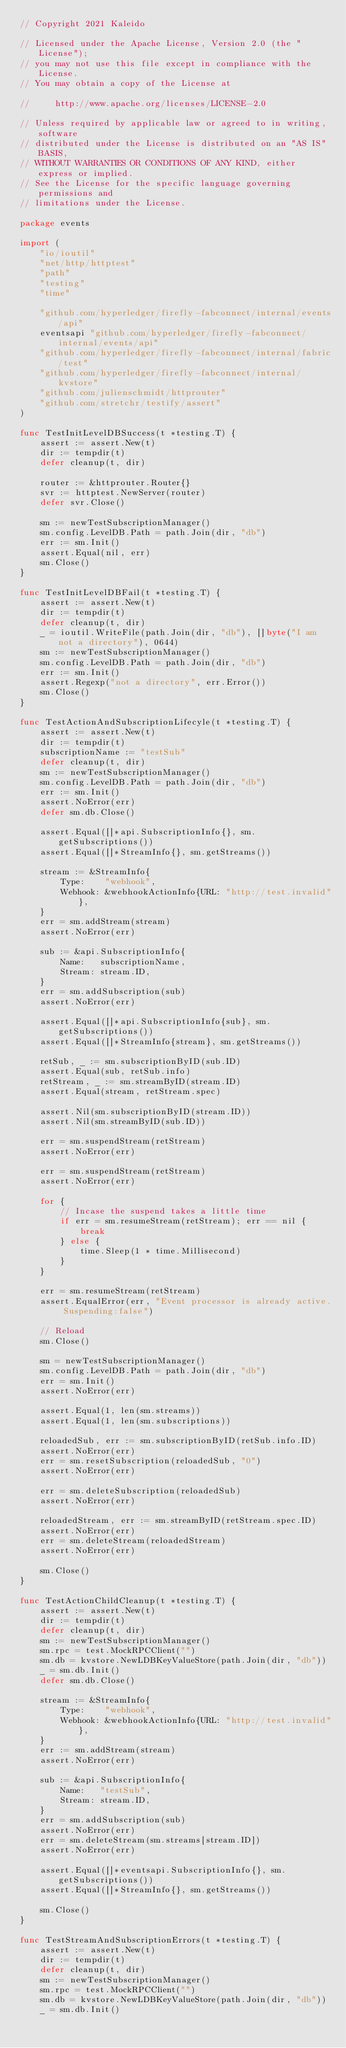<code> <loc_0><loc_0><loc_500><loc_500><_Go_>// Copyright 2021 Kaleido

// Licensed under the Apache License, Version 2.0 (the "License");
// you may not use this file except in compliance with the License.
// You may obtain a copy of the License at

//     http://www.apache.org/licenses/LICENSE-2.0

// Unless required by applicable law or agreed to in writing, software
// distributed under the License is distributed on an "AS IS" BASIS,
// WITHOUT WARRANTIES OR CONDITIONS OF ANY KIND, either express or implied.
// See the License for the specific language governing permissions and
// limitations under the License.

package events

import (
	"io/ioutil"
	"net/http/httptest"
	"path"
	"testing"
	"time"

	"github.com/hyperledger/firefly-fabconnect/internal/events/api"
	eventsapi "github.com/hyperledger/firefly-fabconnect/internal/events/api"
	"github.com/hyperledger/firefly-fabconnect/internal/fabric/test"
	"github.com/hyperledger/firefly-fabconnect/internal/kvstore"
	"github.com/julienschmidt/httprouter"
	"github.com/stretchr/testify/assert"
)

func TestInitLevelDBSuccess(t *testing.T) {
	assert := assert.New(t)
	dir := tempdir(t)
	defer cleanup(t, dir)

	router := &httprouter.Router{}
	svr := httptest.NewServer(router)
	defer svr.Close()

	sm := newTestSubscriptionManager()
	sm.config.LevelDB.Path = path.Join(dir, "db")
	err := sm.Init()
	assert.Equal(nil, err)
	sm.Close()
}

func TestInitLevelDBFail(t *testing.T) {
	assert := assert.New(t)
	dir := tempdir(t)
	defer cleanup(t, dir)
	_ = ioutil.WriteFile(path.Join(dir, "db"), []byte("I am not a directory"), 0644)
	sm := newTestSubscriptionManager()
	sm.config.LevelDB.Path = path.Join(dir, "db")
	err := sm.Init()
	assert.Regexp("not a directory", err.Error())
	sm.Close()
}

func TestActionAndSubscriptionLifecyle(t *testing.T) {
	assert := assert.New(t)
	dir := tempdir(t)
	subscriptionName := "testSub"
	defer cleanup(t, dir)
	sm := newTestSubscriptionManager()
	sm.config.LevelDB.Path = path.Join(dir, "db")
	err := sm.Init()
	assert.NoError(err)
	defer sm.db.Close()

	assert.Equal([]*api.SubscriptionInfo{}, sm.getSubscriptions())
	assert.Equal([]*StreamInfo{}, sm.getStreams())

	stream := &StreamInfo{
		Type:    "webhook",
		Webhook: &webhookActionInfo{URL: "http://test.invalid"},
	}
	err = sm.addStream(stream)
	assert.NoError(err)

	sub := &api.SubscriptionInfo{
		Name:   subscriptionName,
		Stream: stream.ID,
	}
	err = sm.addSubscription(sub)
	assert.NoError(err)

	assert.Equal([]*api.SubscriptionInfo{sub}, sm.getSubscriptions())
	assert.Equal([]*StreamInfo{stream}, sm.getStreams())

	retSub, _ := sm.subscriptionByID(sub.ID)
	assert.Equal(sub, retSub.info)
	retStream, _ := sm.streamByID(stream.ID)
	assert.Equal(stream, retStream.spec)

	assert.Nil(sm.subscriptionByID(stream.ID))
	assert.Nil(sm.streamByID(sub.ID))

	err = sm.suspendStream(retStream)
	assert.NoError(err)

	err = sm.suspendStream(retStream)
	assert.NoError(err)

	for {
		// Incase the suspend takes a little time
		if err = sm.resumeStream(retStream); err == nil {
			break
		} else {
			time.Sleep(1 * time.Millisecond)
		}
	}

	err = sm.resumeStream(retStream)
	assert.EqualError(err, "Event processor is already active. Suspending:false")

	// Reload
	sm.Close()

	sm = newTestSubscriptionManager()
	sm.config.LevelDB.Path = path.Join(dir, "db")
	err = sm.Init()
	assert.NoError(err)

	assert.Equal(1, len(sm.streams))
	assert.Equal(1, len(sm.subscriptions))

	reloadedSub, err := sm.subscriptionByID(retSub.info.ID)
	assert.NoError(err)
	err = sm.resetSubscription(reloadedSub, "0")
	assert.NoError(err)

	err = sm.deleteSubscription(reloadedSub)
	assert.NoError(err)

	reloadedStream, err := sm.streamByID(retStream.spec.ID)
	assert.NoError(err)
	err = sm.deleteStream(reloadedStream)
	assert.NoError(err)

	sm.Close()
}

func TestActionChildCleanup(t *testing.T) {
	assert := assert.New(t)
	dir := tempdir(t)
	defer cleanup(t, dir)
	sm := newTestSubscriptionManager()
	sm.rpc = test.MockRPCClient("")
	sm.db = kvstore.NewLDBKeyValueStore(path.Join(dir, "db"))
	_ = sm.db.Init()
	defer sm.db.Close()

	stream := &StreamInfo{
		Type:    "webhook",
		Webhook: &webhookActionInfo{URL: "http://test.invalid"},
	}
	err := sm.addStream(stream)
	assert.NoError(err)

	sub := &api.SubscriptionInfo{
		Name:   "testSub",
		Stream: stream.ID,
	}
	err = sm.addSubscription(sub)
	assert.NoError(err)
	err = sm.deleteStream(sm.streams[stream.ID])
	assert.NoError(err)

	assert.Equal([]*eventsapi.SubscriptionInfo{}, sm.getSubscriptions())
	assert.Equal([]*StreamInfo{}, sm.getStreams())

	sm.Close()
}

func TestStreamAndSubscriptionErrors(t *testing.T) {
	assert := assert.New(t)
	dir := tempdir(t)
	defer cleanup(t, dir)
	sm := newTestSubscriptionManager()
	sm.rpc = test.MockRPCClient("")
	sm.db = kvstore.NewLDBKeyValueStore(path.Join(dir, "db"))
	_ = sm.db.Init()</code> 